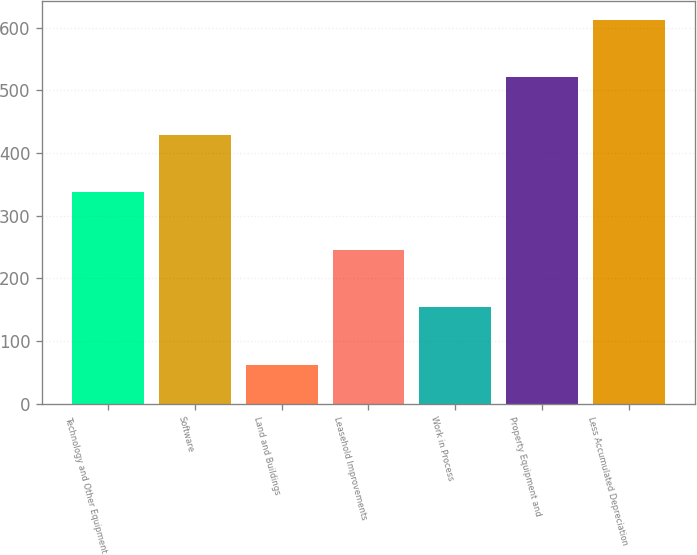Convert chart. <chart><loc_0><loc_0><loc_500><loc_500><bar_chart><fcel>Technology and Other Equipment<fcel>Software<fcel>Land and Buildings<fcel>Leasehold Improvements<fcel>Work in Process<fcel>Property Equipment and<fcel>Less Accumulated Depreciation<nl><fcel>337.49<fcel>429.22<fcel>62.3<fcel>245.76<fcel>154.03<fcel>520.95<fcel>612.68<nl></chart> 